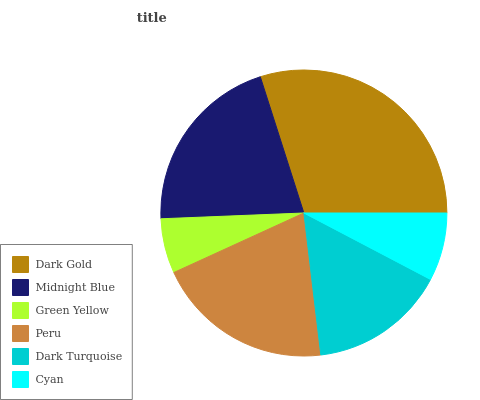Is Green Yellow the minimum?
Answer yes or no. Yes. Is Dark Gold the maximum?
Answer yes or no. Yes. Is Midnight Blue the minimum?
Answer yes or no. No. Is Midnight Blue the maximum?
Answer yes or no. No. Is Dark Gold greater than Midnight Blue?
Answer yes or no. Yes. Is Midnight Blue less than Dark Gold?
Answer yes or no. Yes. Is Midnight Blue greater than Dark Gold?
Answer yes or no. No. Is Dark Gold less than Midnight Blue?
Answer yes or no. No. Is Peru the high median?
Answer yes or no. Yes. Is Dark Turquoise the low median?
Answer yes or no. Yes. Is Dark Gold the high median?
Answer yes or no. No. Is Green Yellow the low median?
Answer yes or no. No. 